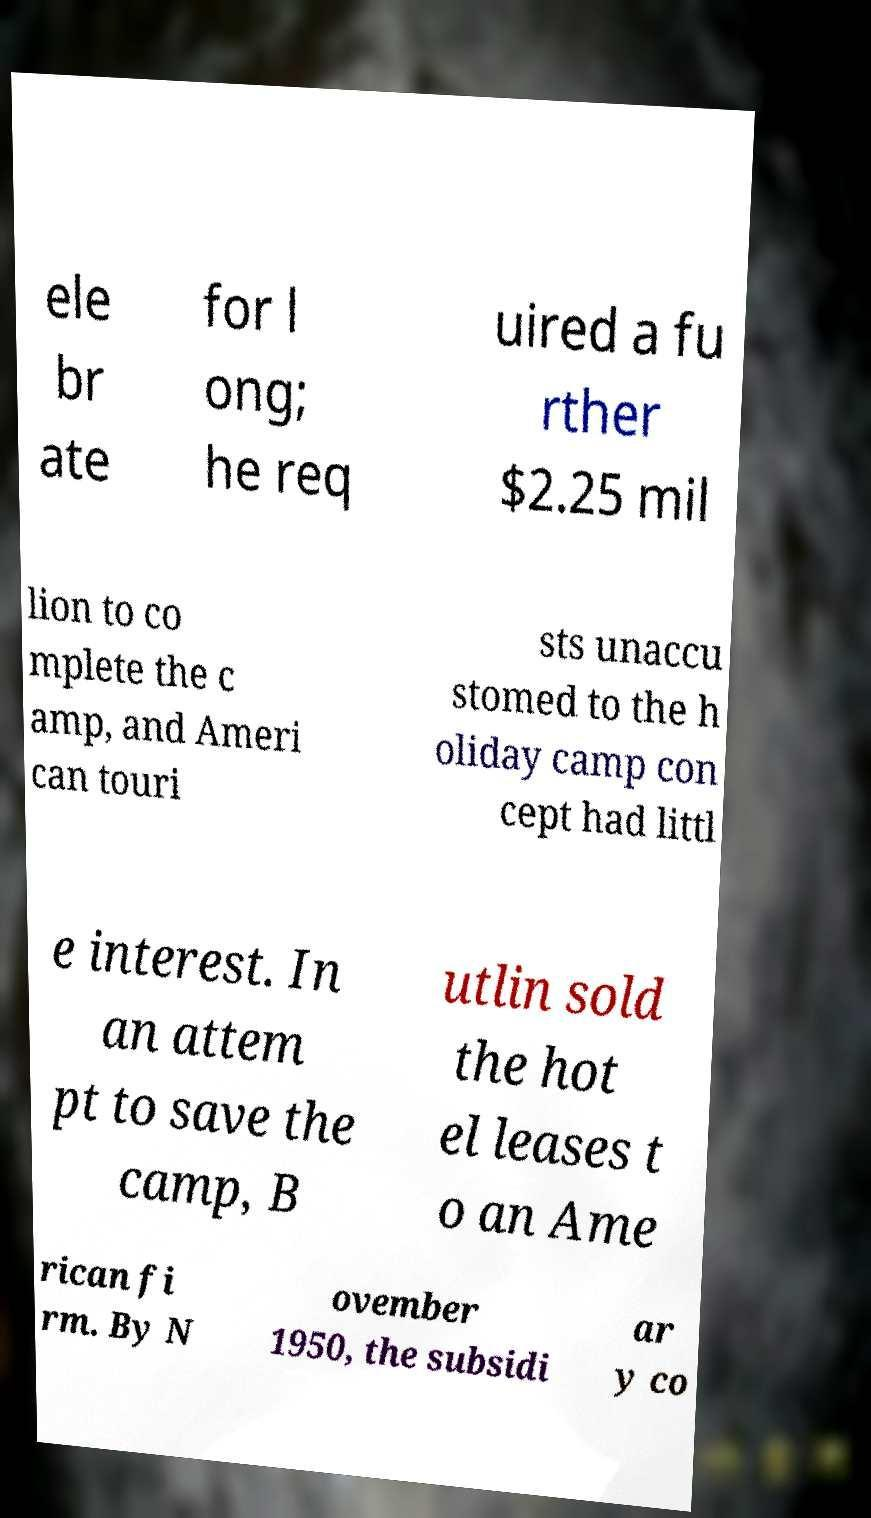Can you read and provide the text displayed in the image?This photo seems to have some interesting text. Can you extract and type it out for me? ele br ate for l ong; he req uired a fu rther $2.25 mil lion to co mplete the c amp, and Ameri can touri sts unaccu stomed to the h oliday camp con cept had littl e interest. In an attem pt to save the camp, B utlin sold the hot el leases t o an Ame rican fi rm. By N ovember 1950, the subsidi ar y co 